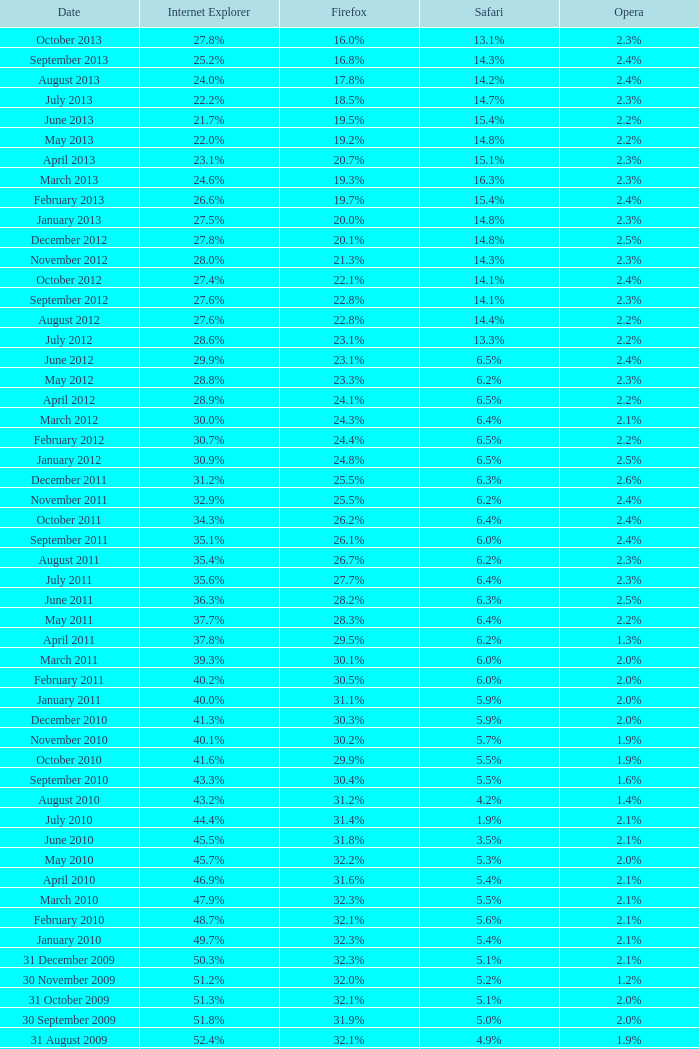Can you parse all the data within this table? {'header': ['Date', 'Internet Explorer', 'Firefox', 'Safari', 'Opera'], 'rows': [['October 2013', '27.8%', '16.0%', '13.1%', '2.3%'], ['September 2013', '25.2%', '16.8%', '14.3%', '2.4%'], ['August 2013', '24.0%', '17.8%', '14.2%', '2.4%'], ['July 2013', '22.2%', '18.5%', '14.7%', '2.3%'], ['June 2013', '21.7%', '19.5%', '15.4%', '2.2%'], ['May 2013', '22.0%', '19.2%', '14.8%', '2.2%'], ['April 2013', '23.1%', '20.7%', '15.1%', '2.3%'], ['March 2013', '24.6%', '19.3%', '16.3%', '2.3%'], ['February 2013', '26.6%', '19.7%', '15.4%', '2.4%'], ['January 2013', '27.5%', '20.0%', '14.8%', '2.3%'], ['December 2012', '27.8%', '20.1%', '14.8%', '2.5%'], ['November 2012', '28.0%', '21.3%', '14.3%', '2.3%'], ['October 2012', '27.4%', '22.1%', '14.1%', '2.4%'], ['September 2012', '27.6%', '22.8%', '14.1%', '2.3%'], ['August 2012', '27.6%', '22.8%', '14.4%', '2.2%'], ['July 2012', '28.6%', '23.1%', '13.3%', '2.2%'], ['June 2012', '29.9%', '23.1%', '6.5%', '2.4%'], ['May 2012', '28.8%', '23.3%', '6.2%', '2.3%'], ['April 2012', '28.9%', '24.1%', '6.5%', '2.2%'], ['March 2012', '30.0%', '24.3%', '6.4%', '2.1%'], ['February 2012', '30.7%', '24.4%', '6.5%', '2.2%'], ['January 2012', '30.9%', '24.8%', '6.5%', '2.5%'], ['December 2011', '31.2%', '25.5%', '6.3%', '2.6%'], ['November 2011', '32.9%', '25.5%', '6.2%', '2.4%'], ['October 2011', '34.3%', '26.2%', '6.4%', '2.4%'], ['September 2011', '35.1%', '26.1%', '6.0%', '2.4%'], ['August 2011', '35.4%', '26.7%', '6.2%', '2.3%'], ['July 2011', '35.6%', '27.7%', '6.4%', '2.3%'], ['June 2011', '36.3%', '28.2%', '6.3%', '2.5%'], ['May 2011', '37.7%', '28.3%', '6.4%', '2.2%'], ['April 2011', '37.8%', '29.5%', '6.2%', '1.3%'], ['March 2011', '39.3%', '30.1%', '6.0%', '2.0%'], ['February 2011', '40.2%', '30.5%', '6.0%', '2.0%'], ['January 2011', '40.0%', '31.1%', '5.9%', '2.0%'], ['December 2010', '41.3%', '30.3%', '5.9%', '2.0%'], ['November 2010', '40.1%', '30.2%', '5.7%', '1.9%'], ['October 2010', '41.6%', '29.9%', '5.5%', '1.9%'], ['September 2010', '43.3%', '30.4%', '5.5%', '1.6%'], ['August 2010', '43.2%', '31.2%', '4.2%', '1.4%'], ['July 2010', '44.4%', '31.4%', '1.9%', '2.1%'], ['June 2010', '45.5%', '31.8%', '3.5%', '2.1%'], ['May 2010', '45.7%', '32.2%', '5.3%', '2.0%'], ['April 2010', '46.9%', '31.6%', '5.4%', '2.1%'], ['March 2010', '47.9%', '32.3%', '5.5%', '2.1%'], ['February 2010', '48.7%', '32.1%', '5.6%', '2.1%'], ['January 2010', '49.7%', '32.3%', '5.4%', '2.1%'], ['31 December 2009', '50.3%', '32.3%', '5.1%', '2.1%'], ['30 November 2009', '51.2%', '32.0%', '5.2%', '1.2%'], ['31 October 2009', '51.3%', '32.1%', '5.1%', '2.0%'], ['30 September 2009', '51.8%', '31.9%', '5.0%', '2.0%'], ['31 August 2009', '52.4%', '32.1%', '4.9%', '1.9%'], ['31 July 2009', '53.1%', '31.7%', '4.6%', '1.8%'], ['30 June 2009', '57.1%', '31.6%', '3.2%', '2.0%'], ['31 May 2009', '57.5%', '31.4%', '3.1%', '2.0%'], ['30 April 2009', '57.6%', '31.6%', '2.9%', '2.0%'], ['31 March 2009', '57.8%', '31.5%', '2.8%', '2.0%'], ['28 February 2009', '58.1%', '31.3%', '2.7%', '2.0%'], ['31 January 2009', '58.4%', '31.1%', '2.7%', '2.0%'], ['31 December 2008', '58.6%', '31.1%', '2.9%', '2.1%'], ['30 November 2008', '59.0%', '30.8%', '3.0%', '2.0%'], ['31 October 2008', '59.4%', '30.6%', '3.0%', '2.0%'], ['30 September 2008', '57.3%', '32.5%', '2.7%', '2.0%'], ['31 August 2008', '58.7%', '31.4%', '2.4%', '2.1%'], ['31 July 2008', '60.9%', '29.7%', '2.4%', '2.0%'], ['30 June 2008', '61.7%', '29.1%', '2.5%', '2.0%'], ['31 May 2008', '61.9%', '28.9%', '2.7%', '2.0%'], ['30 April 2008', '62.0%', '28.8%', '2.8%', '2.0%'], ['31 March 2008', '62.0%', '28.8%', '2.8%', '2.0%'], ['29 February 2008', '62.0%', '28.7%', '2.8%', '2.0%'], ['31 January 2008', '62.2%', '28.7%', '2.7%', '2.0%'], ['1 December 2007', '62.8%', '28.0%', '2.6%', '2.0%'], ['10 November 2007', '63.0%', '27.8%', '2.5%', '2.0%'], ['30 October 2007', '65.5%', '26.3%', '2.3%', '1.8%'], ['20 September 2007', '66.6%', '25.6%', '2.1%', '1.8%'], ['30 August 2007', '66.7%', '25.5%', '2.1%', '1.8%'], ['30 July 2007', '66.9%', '25.1%', '2.2%', '1.8%'], ['30 June 2007', '66.9%', '25.1%', '2.3%', '1.8%'], ['30 May 2007', '67.1%', '24.8%', '2.4%', '1.8%'], ['Date', 'Internet Explorer', 'Firefox', 'Safari', 'Opera']]} On which date did internet explorer achieve 6 31 January 2008. 